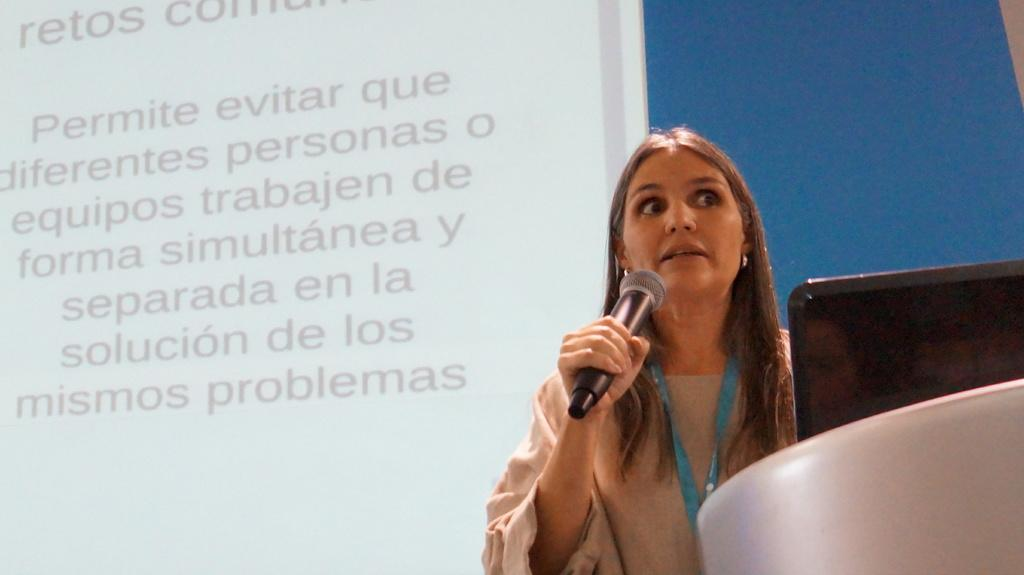Who is present in the image? There is a woman in the image. What is the woman doing in the image? The woman is standing and holding a microphone. What else can be seen in the image besides the woman? There are objects in the image. What is visible in the background of the image? There is a screen in the background of the image. What type of flower is growing on the woman's shoulder in the image? There is no flower present on the woman's shoulder in the image. Is there a scarecrow visible in the image? No, there is no scarecrow present in the image. 